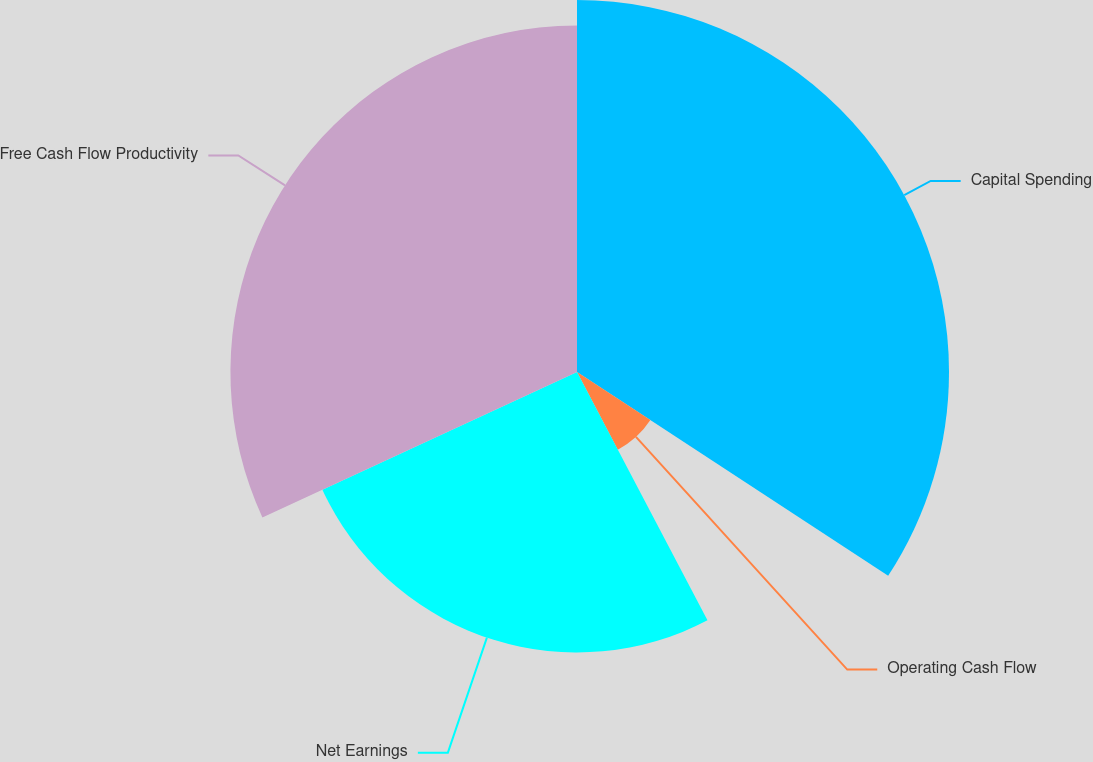Convert chart. <chart><loc_0><loc_0><loc_500><loc_500><pie_chart><fcel>Capital Spending<fcel>Operating Cash Flow<fcel>Net Earnings<fcel>Free Cash Flow Productivity<nl><fcel>34.23%<fcel>8.07%<fcel>25.81%<fcel>31.89%<nl></chart> 